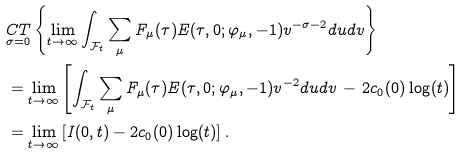Convert formula to latex. <formula><loc_0><loc_0><loc_500><loc_500>& \underset { \sigma = 0 } { C T } \left \{ \lim _ { t \to \infty } \int _ { \mathcal { F } _ { t } } \sum _ { \mu } F _ { \mu } ( \tau ) E ( \tau , 0 ; \varphi _ { \mu } , - 1 ) v ^ { - \sigma - 2 } d u d v \right \} \\ & = \lim _ { t \to \infty } \left [ \int _ { \mathcal { F } _ { t } } \sum _ { \mu } F _ { \mu } ( \tau ) E ( \tau , 0 ; \varphi _ { \mu } , - 1 ) v ^ { - 2 } d u d v \, - \, 2 c _ { 0 } ( 0 ) \log ( t ) \right ] \\ & = \lim _ { t \to \infty } \left [ I ( 0 , t ) - 2 c _ { 0 } ( 0 ) \log ( t ) \right ] .</formula> 